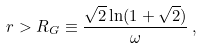<formula> <loc_0><loc_0><loc_500><loc_500>r > R _ { G } \equiv \frac { \sqrt { 2 } \ln ( 1 + \sqrt { 2 } ) } { \omega } \, ,</formula> 